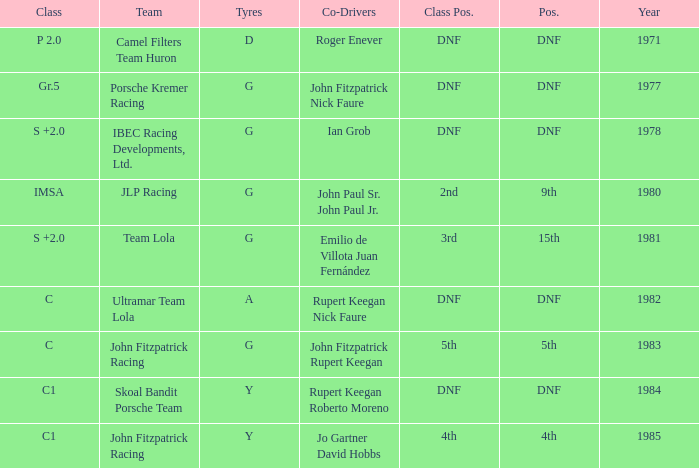What is the earliest year that had a co-driver of Roger Enever? 1971.0. 